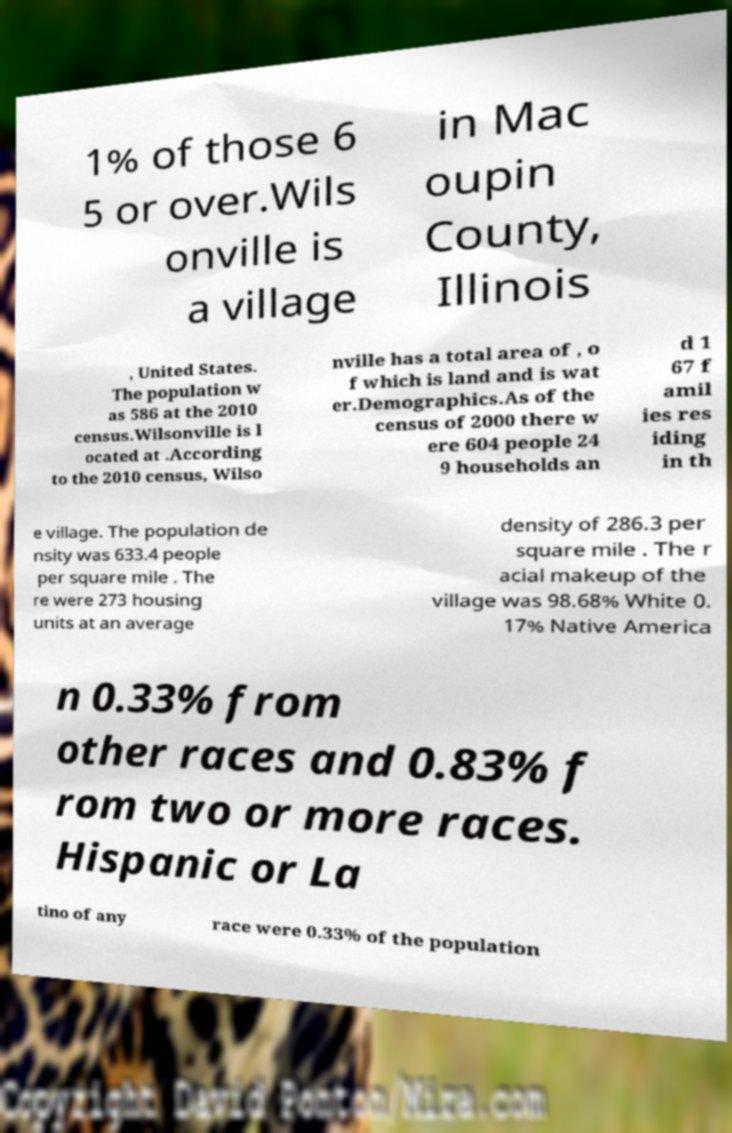Could you assist in decoding the text presented in this image and type it out clearly? 1% of those 6 5 or over.Wils onville is a village in Mac oupin County, Illinois , United States. The population w as 586 at the 2010 census.Wilsonville is l ocated at .According to the 2010 census, Wilso nville has a total area of , o f which is land and is wat er.Demographics.As of the census of 2000 there w ere 604 people 24 9 households an d 1 67 f amil ies res iding in th e village. The population de nsity was 633.4 people per square mile . The re were 273 housing units at an average density of 286.3 per square mile . The r acial makeup of the village was 98.68% White 0. 17% Native America n 0.33% from other races and 0.83% f rom two or more races. Hispanic or La tino of any race were 0.33% of the population 